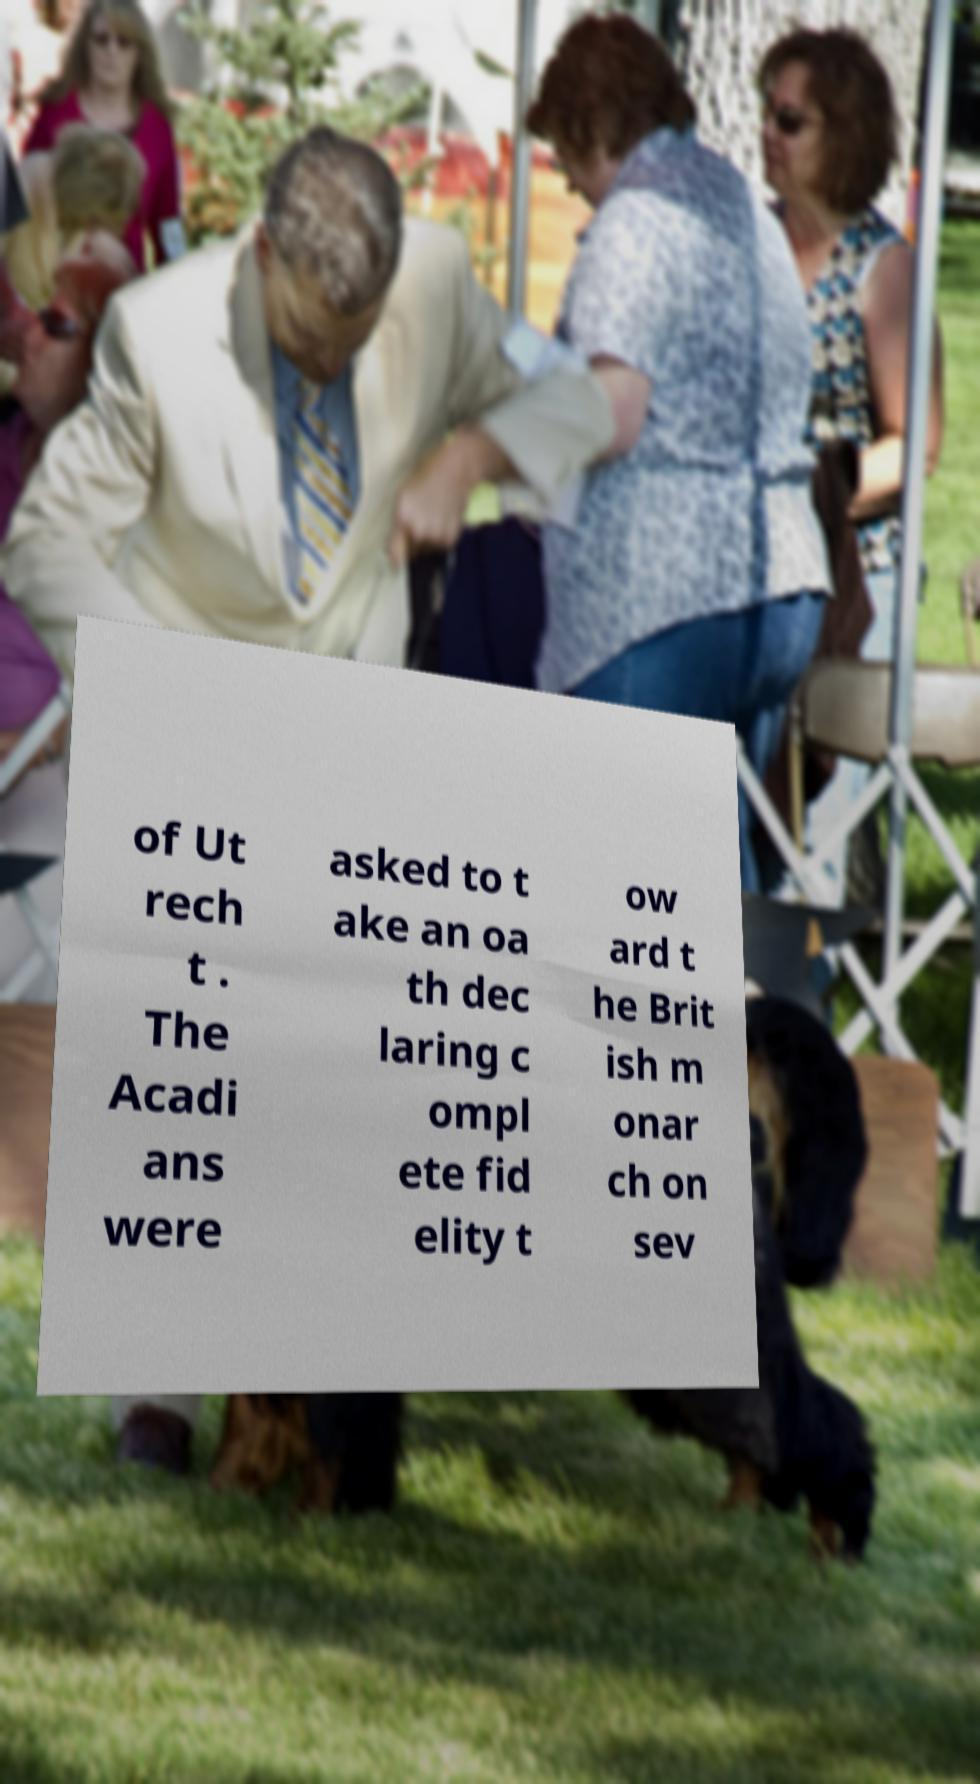Can you read and provide the text displayed in the image?This photo seems to have some interesting text. Can you extract and type it out for me? of Ut rech t . The Acadi ans were asked to t ake an oa th dec laring c ompl ete fid elity t ow ard t he Brit ish m onar ch on sev 